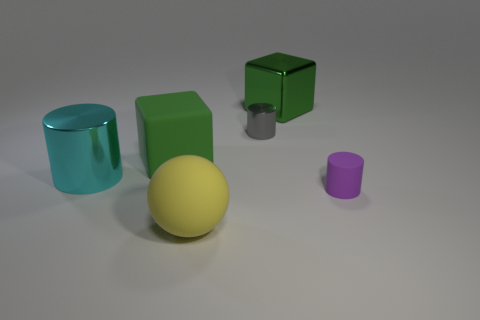What number of gray cylinders are to the left of the tiny cylinder behind the purple matte cylinder?
Make the answer very short. 0. What size is the matte thing that is the same color as the metal cube?
Keep it short and to the point. Large. What number of objects are either large yellow rubber objects or big rubber objects that are behind the small matte cylinder?
Your response must be concise. 2. Are there any small purple objects made of the same material as the large sphere?
Provide a short and direct response. Yes. What number of things are in front of the shiny cube and to the left of the purple cylinder?
Provide a succinct answer. 4. There is a large block that is right of the big yellow matte thing; what is it made of?
Offer a very short reply. Metal. What is the size of the purple object that is the same material as the large ball?
Your answer should be compact. Small. There is a small gray cylinder; are there any green shiny cubes on the right side of it?
Provide a succinct answer. Yes. There is another shiny thing that is the same shape as the gray object; what is its size?
Your response must be concise. Large. There is a tiny rubber cylinder; is it the same color as the cube to the right of the yellow matte thing?
Make the answer very short. No. 